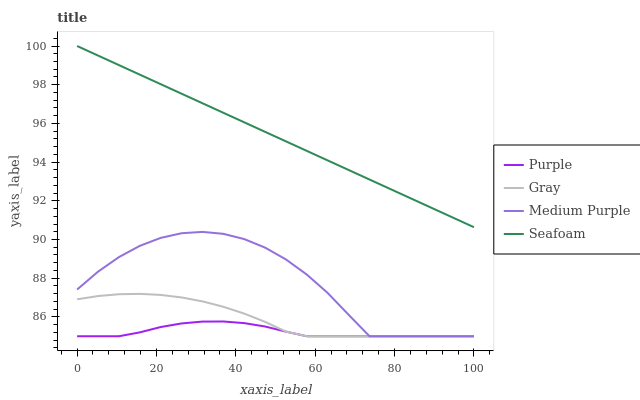Does Gray have the minimum area under the curve?
Answer yes or no. No. Does Gray have the maximum area under the curve?
Answer yes or no. No. Is Gray the smoothest?
Answer yes or no. No. Is Gray the roughest?
Answer yes or no. No. Does Seafoam have the lowest value?
Answer yes or no. No. Does Gray have the highest value?
Answer yes or no. No. Is Purple less than Seafoam?
Answer yes or no. Yes. Is Seafoam greater than Gray?
Answer yes or no. Yes. Does Purple intersect Seafoam?
Answer yes or no. No. 